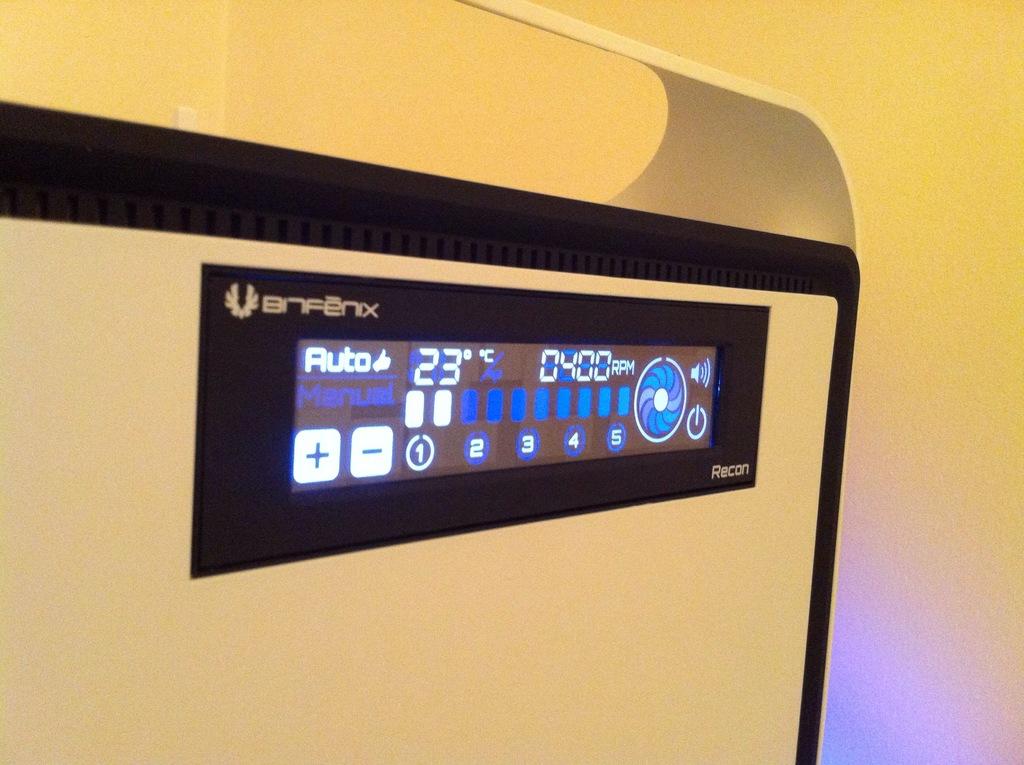What is the temperature?
Your response must be concise. 23. How many rpms is the machine set to?
Make the answer very short. 400. 